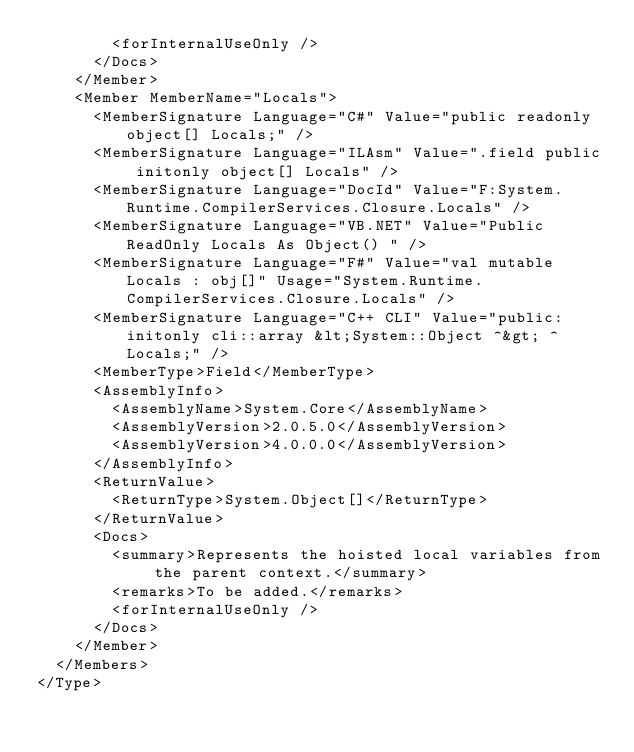Convert code to text. <code><loc_0><loc_0><loc_500><loc_500><_XML_>        <forInternalUseOnly />
      </Docs>
    </Member>
    <Member MemberName="Locals">
      <MemberSignature Language="C#" Value="public readonly object[] Locals;" />
      <MemberSignature Language="ILAsm" Value=".field public initonly object[] Locals" />
      <MemberSignature Language="DocId" Value="F:System.Runtime.CompilerServices.Closure.Locals" />
      <MemberSignature Language="VB.NET" Value="Public ReadOnly Locals As Object() " />
      <MemberSignature Language="F#" Value="val mutable Locals : obj[]" Usage="System.Runtime.CompilerServices.Closure.Locals" />
      <MemberSignature Language="C++ CLI" Value="public: initonly cli::array &lt;System::Object ^&gt; ^ Locals;" />
      <MemberType>Field</MemberType>
      <AssemblyInfo>
        <AssemblyName>System.Core</AssemblyName>
        <AssemblyVersion>2.0.5.0</AssemblyVersion>
        <AssemblyVersion>4.0.0.0</AssemblyVersion>
      </AssemblyInfo>
      <ReturnValue>
        <ReturnType>System.Object[]</ReturnType>
      </ReturnValue>
      <Docs>
        <summary>Represents the hoisted local variables from the parent context.</summary>
        <remarks>To be added.</remarks>
        <forInternalUseOnly />
      </Docs>
    </Member>
  </Members>
</Type>
</code> 